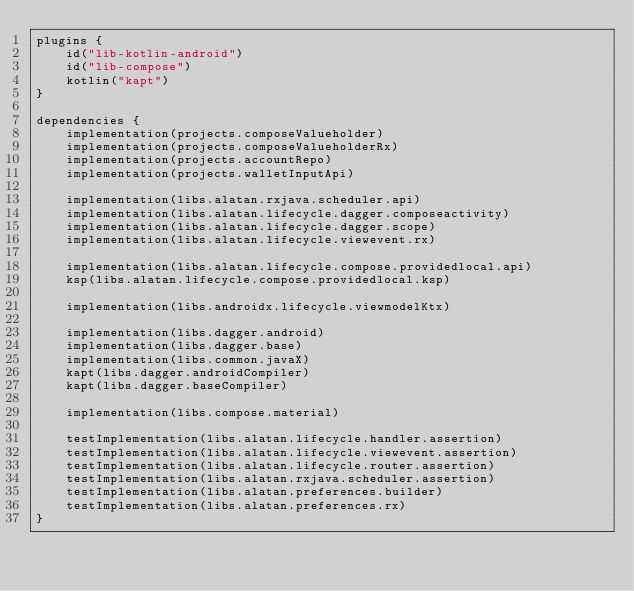<code> <loc_0><loc_0><loc_500><loc_500><_Kotlin_>plugins {
    id("lib-kotlin-android")
    id("lib-compose")
    kotlin("kapt")
}

dependencies {
    implementation(projects.composeValueholder)
    implementation(projects.composeValueholderRx)
    implementation(projects.accountRepo)
    implementation(projects.walletInputApi)

    implementation(libs.alatan.rxjava.scheduler.api)
    implementation(libs.alatan.lifecycle.dagger.composeactivity)
    implementation(libs.alatan.lifecycle.dagger.scope)
    implementation(libs.alatan.lifecycle.viewevent.rx)

    implementation(libs.alatan.lifecycle.compose.providedlocal.api)
    ksp(libs.alatan.lifecycle.compose.providedlocal.ksp)

    implementation(libs.androidx.lifecycle.viewmodelKtx)

    implementation(libs.dagger.android)
    implementation(libs.dagger.base)
    implementation(libs.common.javaX)
    kapt(libs.dagger.androidCompiler)
    kapt(libs.dagger.baseCompiler)

    implementation(libs.compose.material)

    testImplementation(libs.alatan.lifecycle.handler.assertion)
    testImplementation(libs.alatan.lifecycle.viewevent.assertion)
    testImplementation(libs.alatan.lifecycle.router.assertion)
    testImplementation(libs.alatan.rxjava.scheduler.assertion)
    testImplementation(libs.alatan.preferences.builder)
    testImplementation(libs.alatan.preferences.rx)
}</code> 